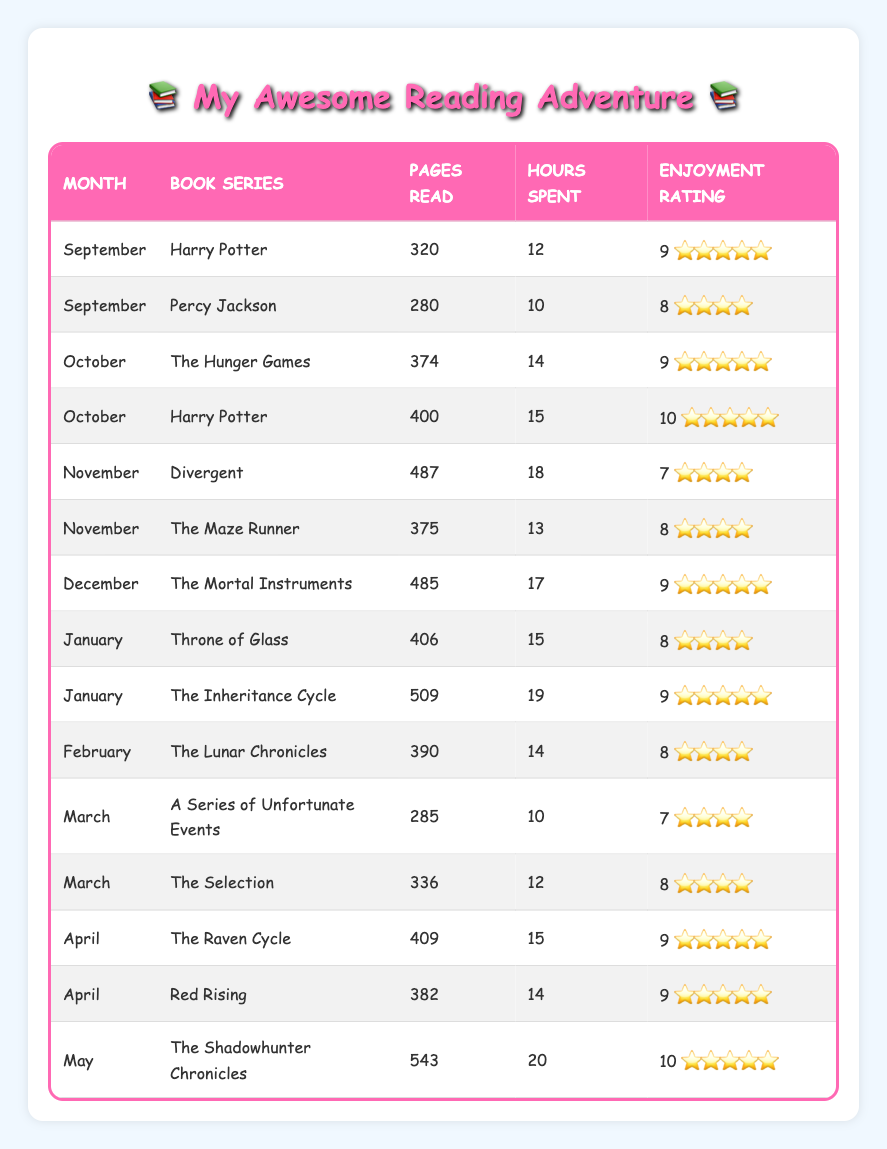What is the highest enjoyment rating among the book series? The enjoyment ratings are: Harry Potter (9, 10), Percy Jackson (8), The Hunger Games (9), Divergent (7), The Maze Runner (8), The Mortal Instruments (9), Throne of Glass (8), The Inheritance Cycle (9), The Lunar Chronicles (8), A Series of Unfortunate Events (7), The Selection (8), The Raven Cycle (9), Red Rising (9), and The Shadowhunter Chronicles (10). The highest rating is 10 for The Shadowhunter Chronicles.
Answer: 10 In which month did I read the most pages? The pages read per month are: September (600 total), October (774 total), November (862 total), December (485), January (915 total), February (390), March (621 total), April (791 total), and May (543). The highest total is 915 in January.
Answer: January What is the average number of hours spent reading per month? The total hours spent are: 12 + 10 + 14 + 15 + 18 + 13 + 17 + 15 + 19 + 14 + 10 + 12 + 15 + 14 + 20 = 252 hours. There are 15 entries, so average hours = 252 / 15 = 16.8 hours.
Answer: 16.8 Did I enjoy reading "Divergent" more than "The Maze Runner"? The enjoyment rating for Divergent is 7 and for The Maze Runner is 8. Since 7 is less than 8, I enjoyed The Maze Runner more.
Answer: No How many pages did I read in total for the Harry Potter series? The pages read for Harry Potter are: 320 (September) + 400 (October) = 720 pages.
Answer: 720 Which book series took the most hours to finish? The hours spent are: Harry Potter (27 hours), The Mortal Instruments (17 hours), The Inheritance Cycle (19 hours), The Shadowhunter Chronicles (20 hours), and Divergent has 18 hours. Harry Potter has the maximum hours (27).
Answer: Harry Potter What is the total pages read for all book series combined over the school year? The total pages read are: 320 + 280 + 374 + 400 + 487 + 375 + 485 + 406 + 509 + 390 + 285 + 336 + 409 + 382 + 543 = 5,470 pages.
Answer: 5470 During which month did I read "The Lunar Chronicles"? The Lunar Chronicles were read in February according to the table entry for that month.
Answer: February Which month had the highest average enjoyment rating? The average enjoyment ratings per month are: September (8.5), October (9.5), November (7.5), December (9), January (8.5), February (8), March (7.5), April (9), and May (10). The highest average is in May.
Answer: May 